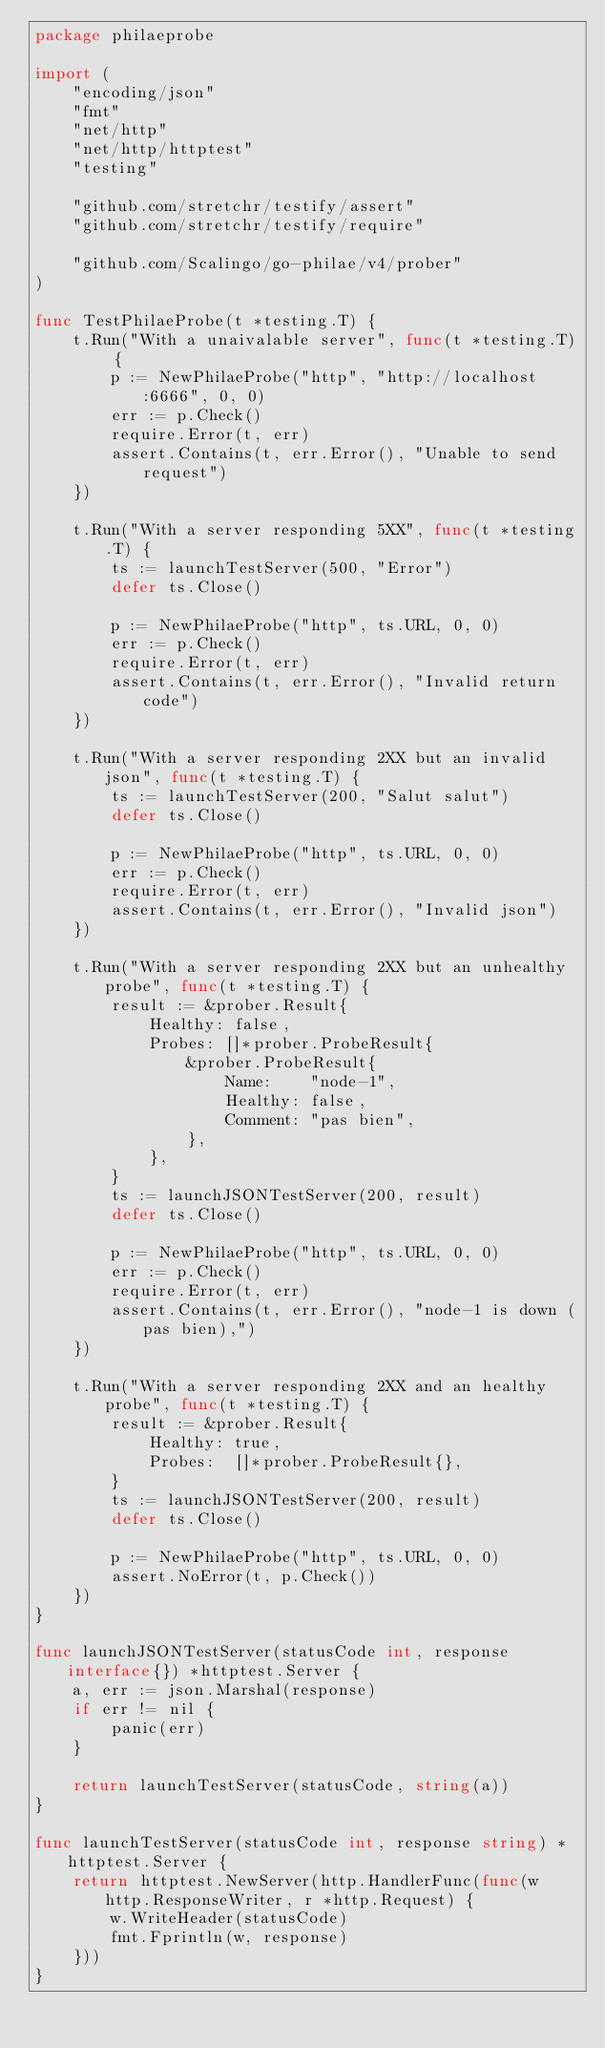Convert code to text. <code><loc_0><loc_0><loc_500><loc_500><_Go_>package philaeprobe

import (
	"encoding/json"
	"fmt"
	"net/http"
	"net/http/httptest"
	"testing"

	"github.com/stretchr/testify/assert"
	"github.com/stretchr/testify/require"

	"github.com/Scalingo/go-philae/v4/prober"
)

func TestPhilaeProbe(t *testing.T) {
	t.Run("With a unaivalable server", func(t *testing.T) {
		p := NewPhilaeProbe("http", "http://localhost:6666", 0, 0)
		err := p.Check()
		require.Error(t, err)
		assert.Contains(t, err.Error(), "Unable to send request")
	})

	t.Run("With a server responding 5XX", func(t *testing.T) {
		ts := launchTestServer(500, "Error")
		defer ts.Close()

		p := NewPhilaeProbe("http", ts.URL, 0, 0)
		err := p.Check()
		require.Error(t, err)
		assert.Contains(t, err.Error(), "Invalid return code")
	})

	t.Run("With a server responding 2XX but an invalid json", func(t *testing.T) {
		ts := launchTestServer(200, "Salut salut")
		defer ts.Close()

		p := NewPhilaeProbe("http", ts.URL, 0, 0)
		err := p.Check()
		require.Error(t, err)
		assert.Contains(t, err.Error(), "Invalid json")
	})

	t.Run("With a server responding 2XX but an unhealthy probe", func(t *testing.T) {
		result := &prober.Result{
			Healthy: false,
			Probes: []*prober.ProbeResult{
				&prober.ProbeResult{
					Name:    "node-1",
					Healthy: false,
					Comment: "pas bien",
				},
			},
		}
		ts := launchJSONTestServer(200, result)
		defer ts.Close()

		p := NewPhilaeProbe("http", ts.URL, 0, 0)
		err := p.Check()
		require.Error(t, err)
		assert.Contains(t, err.Error(), "node-1 is down (pas bien),")
	})

	t.Run("With a server responding 2XX and an healthy probe", func(t *testing.T) {
		result := &prober.Result{
			Healthy: true,
			Probes:  []*prober.ProbeResult{},
		}
		ts := launchJSONTestServer(200, result)
		defer ts.Close()

		p := NewPhilaeProbe("http", ts.URL, 0, 0)
		assert.NoError(t, p.Check())
	})
}

func launchJSONTestServer(statusCode int, response interface{}) *httptest.Server {
	a, err := json.Marshal(response)
	if err != nil {
		panic(err)
	}

	return launchTestServer(statusCode, string(a))
}

func launchTestServer(statusCode int, response string) *httptest.Server {
	return httptest.NewServer(http.HandlerFunc(func(w http.ResponseWriter, r *http.Request) {
		w.WriteHeader(statusCode)
		fmt.Fprintln(w, response)
	}))
}
</code> 